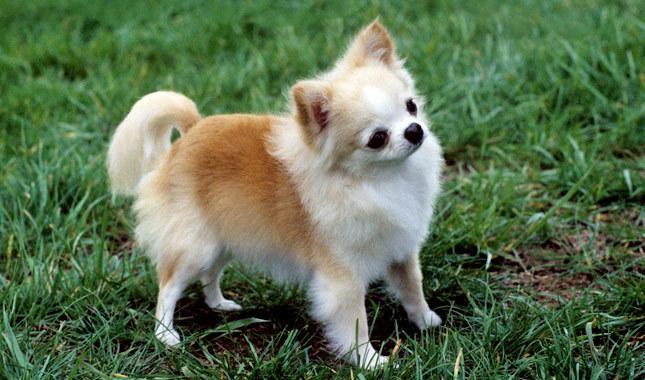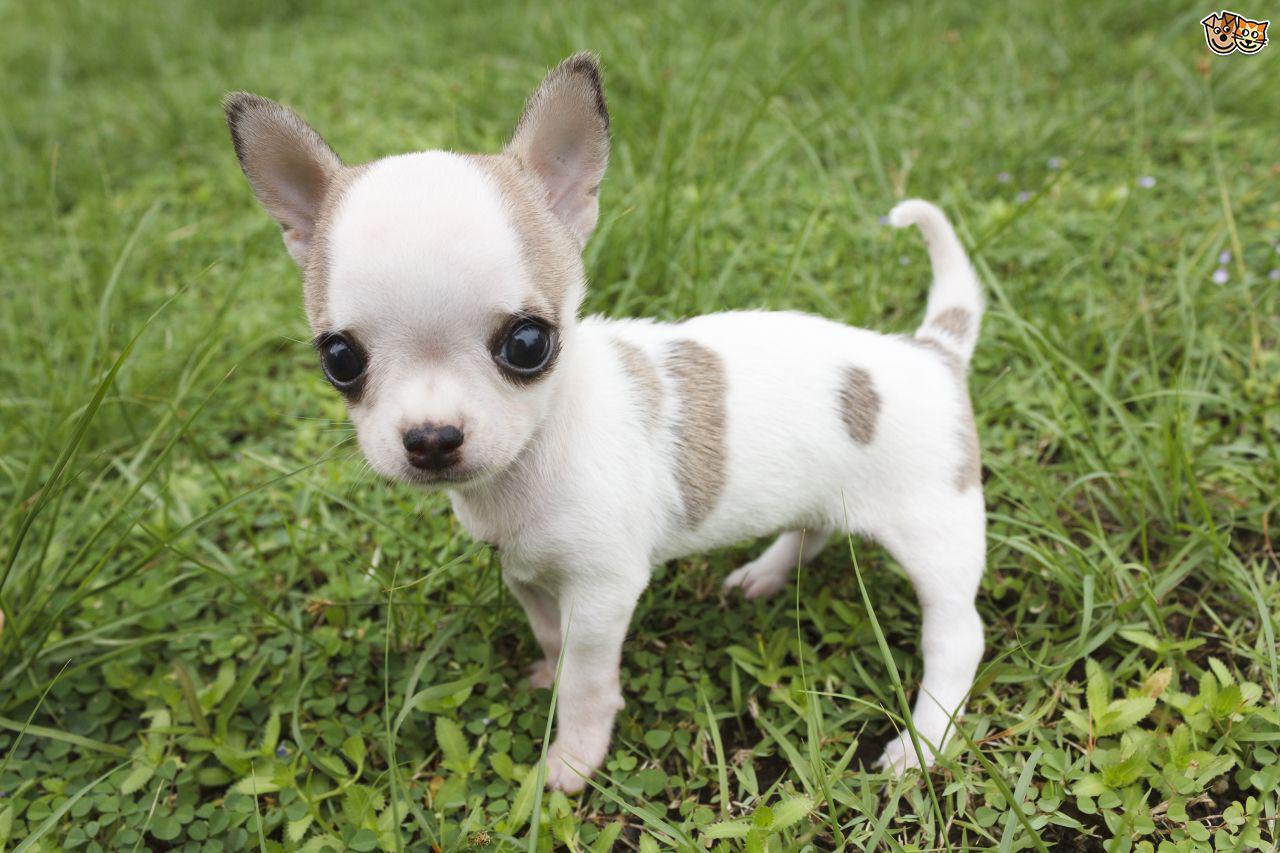The first image is the image on the left, the second image is the image on the right. For the images displayed, is the sentence "All dogs are standing on grass." factually correct? Answer yes or no. Yes. 